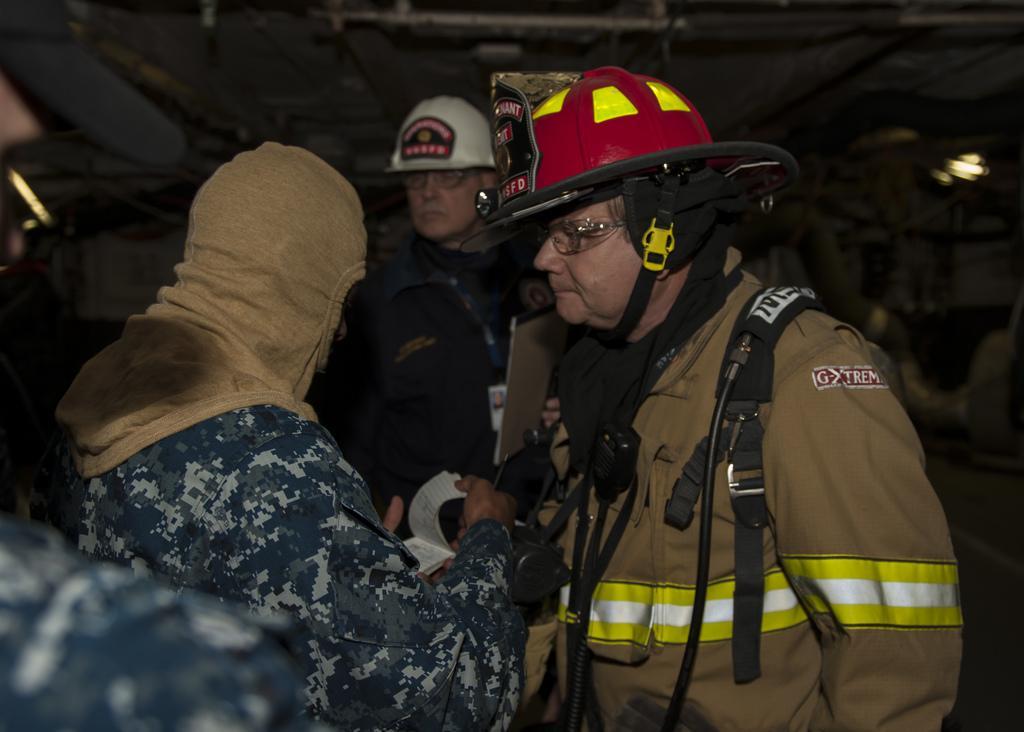Can you describe this image briefly? In this picture there are firefighters and soldiers. In the background there is demolished building. 